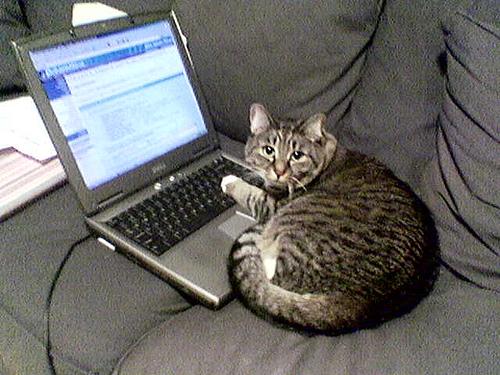Is the cat watching TV?
Be succinct. No. Is this cat warming his paws?
Answer briefly. No. Does the cat know how to use the computer?
Give a very brief answer. No. What color is the sofa?
Quick response, please. Gray. Is the cat asleep?
Give a very brief answer. No. Is the cat typing?
Short answer required. No. What is the cat laying on?
Keep it brief. Laptop. 